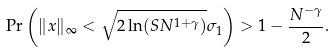<formula> <loc_0><loc_0><loc_500><loc_500>\Pr \left ( \| x \| _ { \infty } < \sqrt { 2 \ln ( S N ^ { 1 + \gamma } ) } \sigma _ { 1 } \right ) > 1 - \frac { N ^ { - \gamma } } { 2 } .</formula> 